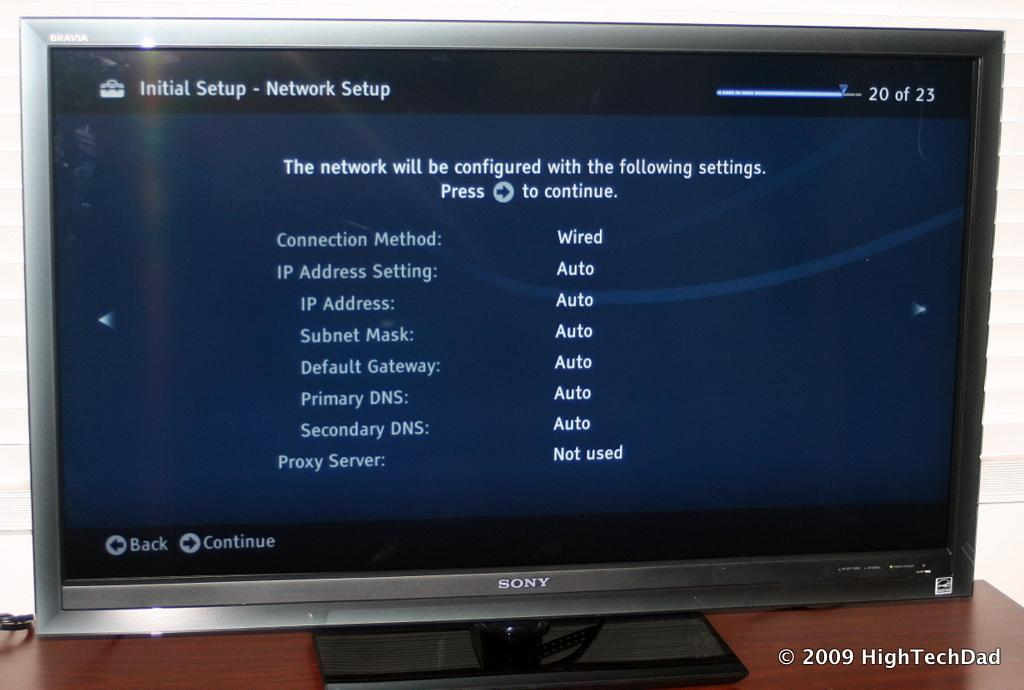<image>
Offer a succinct explanation of the picture presented. a Sony computer monitor has Initial Setup on the screen 